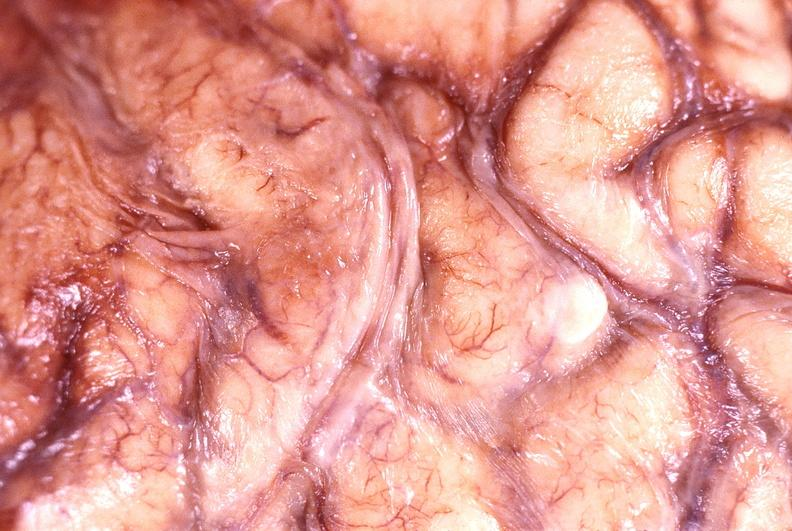what is present?
Answer the question using a single word or phrase. Nervous 